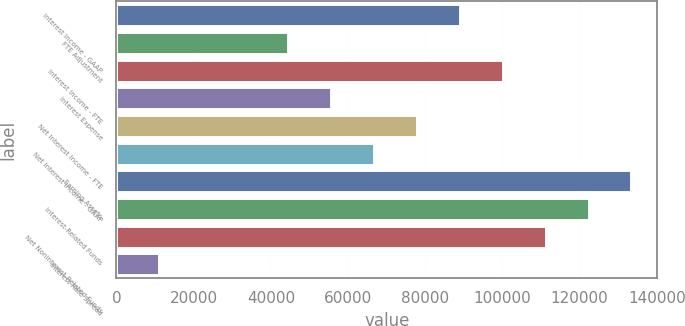Convert chart. <chart><loc_0><loc_0><loc_500><loc_500><bar_chart><fcel>Interest Income - GAAP<fcel>FTE Adjustment<fcel>Interest Income - FTE<fcel>Interest Expense<fcel>Net Interest Income - FTE<fcel>Net Interest Income - GAAP<fcel>Earning Assets<fcel>Interest-Related Funds<fcel>Net Noninterest-Related Funds<fcel>Interest Rate Spread<nl><fcel>88942.7<fcel>44471.5<fcel>100061<fcel>55589.3<fcel>77824.9<fcel>66707.1<fcel>133414<fcel>122296<fcel>111178<fcel>11118.1<nl></chart> 